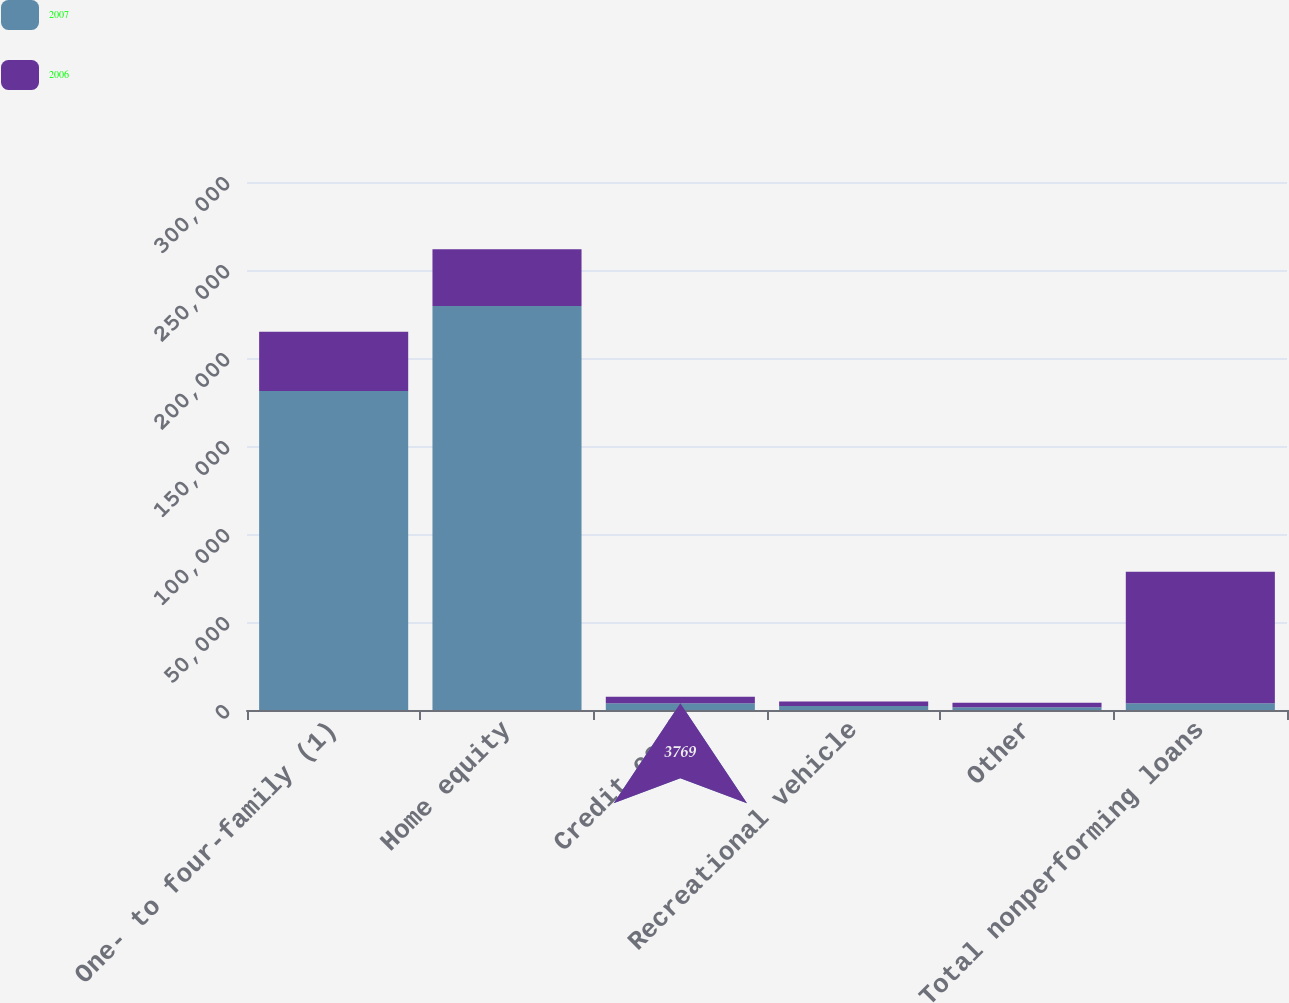Convert chart. <chart><loc_0><loc_0><loc_500><loc_500><stacked_bar_chart><ecel><fcel>One- to four-family (1)<fcel>Home equity<fcel>Credit card<fcel>Recreational vehicle<fcel>Other<fcel>Total nonperforming loans<nl><fcel>2007<fcel>181315<fcel>229523<fcel>3769<fcel>2235<fcel>1600<fcel>3795<nl><fcel>2006<fcel>33588<fcel>32216<fcel>3795<fcel>2579<fcel>2532<fcel>74710<nl></chart> 